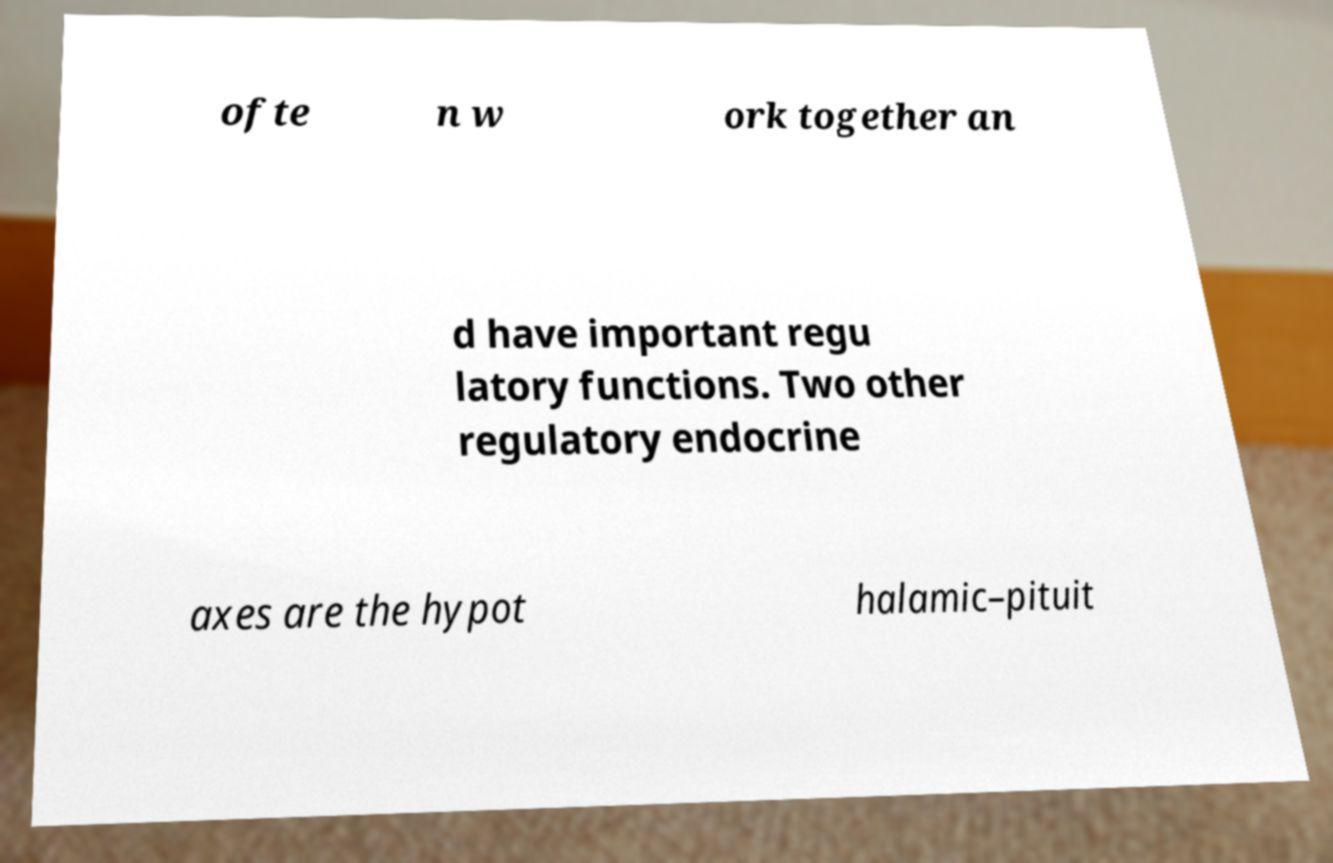Please identify and transcribe the text found in this image. ofte n w ork together an d have important regu latory functions. Two other regulatory endocrine axes are the hypot halamic–pituit 